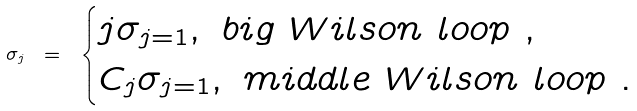<formula> <loc_0><loc_0><loc_500><loc_500>\sigma _ { j } \ = \ \begin{cases} j \sigma _ { j = 1 } , \ b i g \ W i l s o n \ l o o p \ , \\ C _ { j } \sigma _ { j = 1 } , \ m i d d l e \ W i l s o n \ l o o p \ . \end{cases}</formula> 